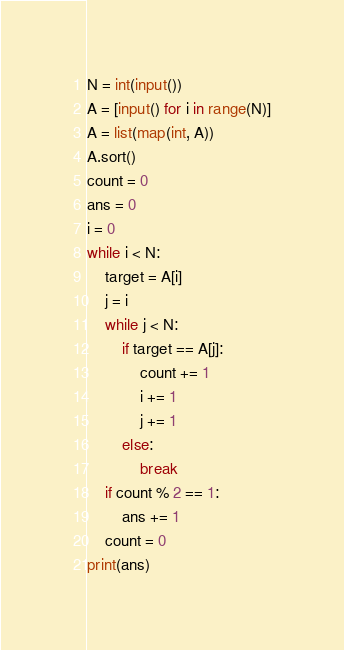<code> <loc_0><loc_0><loc_500><loc_500><_Python_>N = int(input())
A = [input() for i in range(N)]
A = list(map(int, A))
A.sort()
count = 0
ans = 0
i = 0
while i < N:
    target = A[i]
    j = i
    while j < N:
        if target == A[j]:
            count += 1
            i += 1
            j += 1
        else:
            break
    if count % 2 == 1:
        ans += 1
    count = 0
print(ans)</code> 